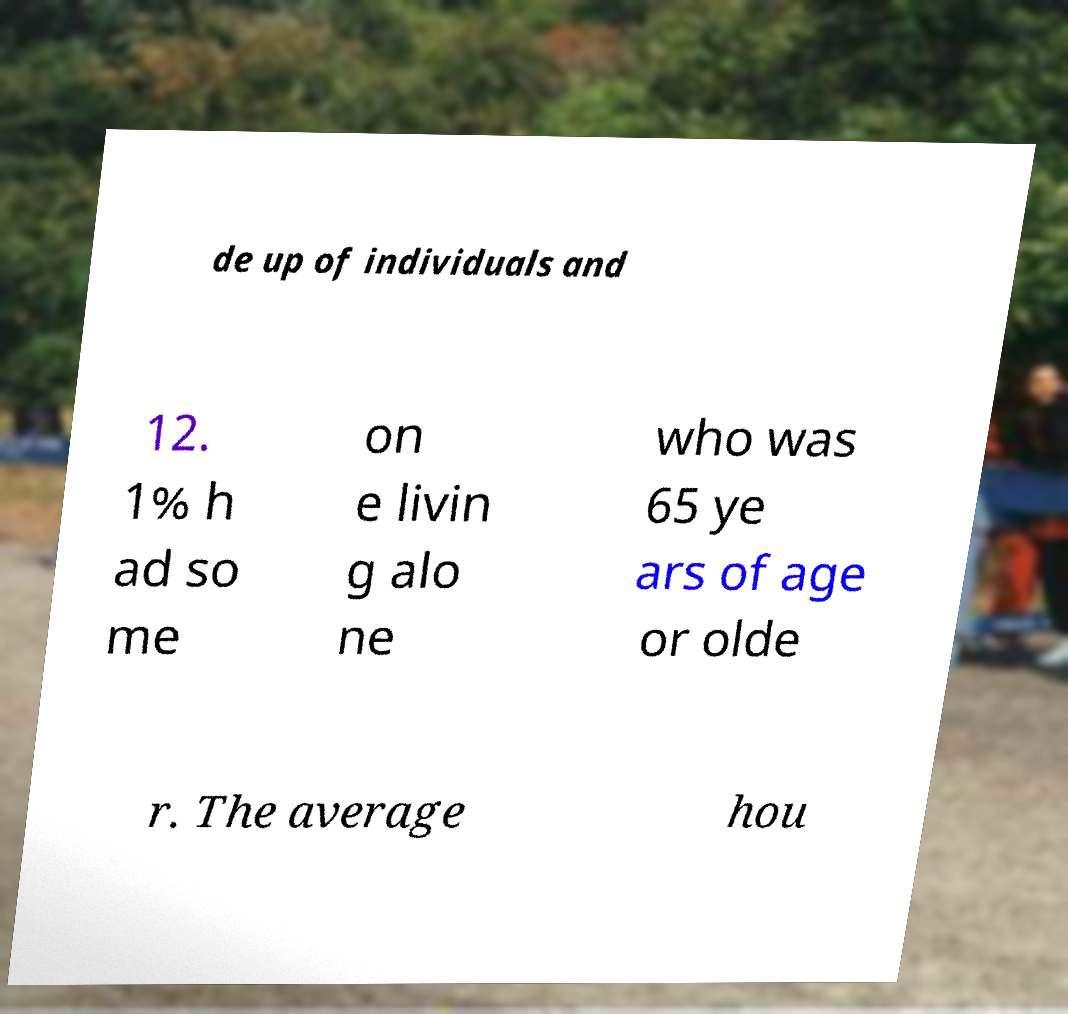There's text embedded in this image that I need extracted. Can you transcribe it verbatim? de up of individuals and 12. 1% h ad so me on e livin g alo ne who was 65 ye ars of age or olde r. The average hou 